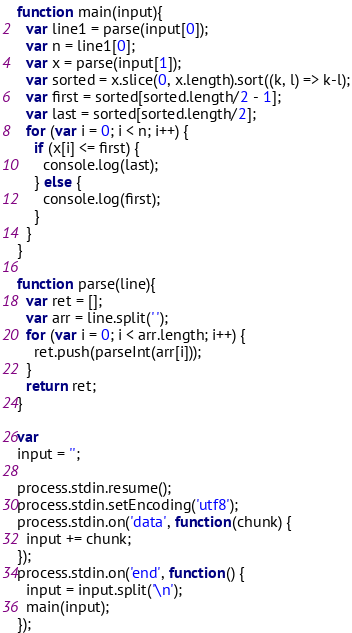Convert code to text. <code><loc_0><loc_0><loc_500><loc_500><_JavaScript_>function main(input){
  var line1 = parse(input[0]);
  var n = line1[0];
  var x = parse(input[1]);
  var sorted = x.slice(0, x.length).sort((k, l) => k-l);
  var first = sorted[sorted.length/2 - 1];
  var last = sorted[sorted.length/2];
  for (var i = 0; i < n; i++) {
    if (x[i] <= first) {
      console.log(last);
    } else {
      console.log(first);
    }
  }
}
 
function parse(line){
  var ret = [];
  var arr = line.split(' ');
  for (var i = 0; i < arr.length; i++) {
    ret.push(parseInt(arr[i]));
  }
  return ret;
}
 
var
input = '';
 
process.stdin.resume();
process.stdin.setEncoding('utf8');
process.stdin.on('data', function(chunk) {
  input += chunk;
});
process.stdin.on('end', function() {
  input = input.split('\n');
  main(input);
});
</code> 